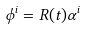<formula> <loc_0><loc_0><loc_500><loc_500>\phi ^ { i } = R ( t ) \alpha ^ { i }</formula> 